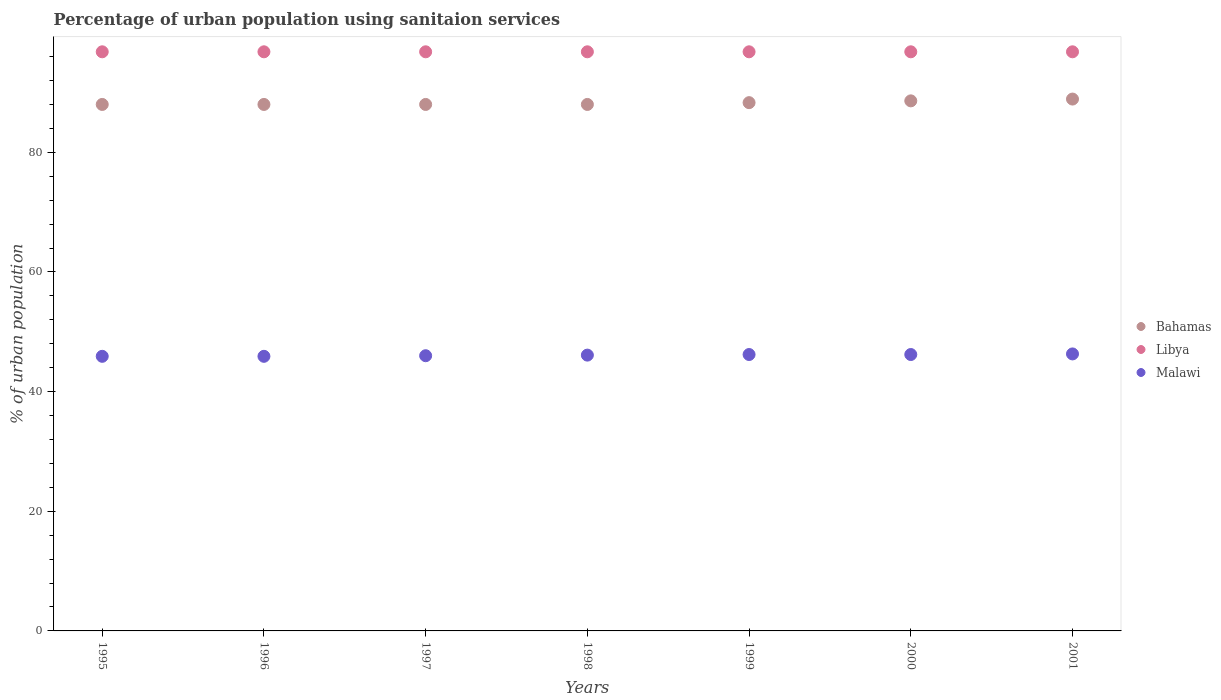Across all years, what is the maximum percentage of urban population using sanitaion services in Libya?
Ensure brevity in your answer.  96.8. Across all years, what is the minimum percentage of urban population using sanitaion services in Libya?
Offer a terse response. 96.8. In which year was the percentage of urban population using sanitaion services in Malawi maximum?
Ensure brevity in your answer.  2001. In which year was the percentage of urban population using sanitaion services in Libya minimum?
Provide a short and direct response. 1995. What is the total percentage of urban population using sanitaion services in Bahamas in the graph?
Offer a very short reply. 617.8. What is the difference between the percentage of urban population using sanitaion services in Malawi in 1999 and that in 2001?
Offer a terse response. -0.1. What is the difference between the percentage of urban population using sanitaion services in Libya in 1995 and the percentage of urban population using sanitaion services in Malawi in 1996?
Your answer should be very brief. 50.9. What is the average percentage of urban population using sanitaion services in Bahamas per year?
Your answer should be very brief. 88.26. In the year 1996, what is the difference between the percentage of urban population using sanitaion services in Malawi and percentage of urban population using sanitaion services in Libya?
Provide a short and direct response. -50.9. In how many years, is the percentage of urban population using sanitaion services in Bahamas greater than 88 %?
Provide a succinct answer. 3. What is the ratio of the percentage of urban population using sanitaion services in Malawi in 1997 to that in 2001?
Make the answer very short. 0.99. Is the difference between the percentage of urban population using sanitaion services in Malawi in 1998 and 1999 greater than the difference between the percentage of urban population using sanitaion services in Libya in 1998 and 1999?
Your response must be concise. No. What is the difference between the highest and the second highest percentage of urban population using sanitaion services in Bahamas?
Offer a terse response. 0.3. What is the difference between the highest and the lowest percentage of urban population using sanitaion services in Bahamas?
Make the answer very short. 0.9. Is the percentage of urban population using sanitaion services in Libya strictly greater than the percentage of urban population using sanitaion services in Bahamas over the years?
Your response must be concise. Yes. Is the percentage of urban population using sanitaion services in Libya strictly less than the percentage of urban population using sanitaion services in Malawi over the years?
Keep it short and to the point. No. How many years are there in the graph?
Ensure brevity in your answer.  7. What is the difference between two consecutive major ticks on the Y-axis?
Offer a terse response. 20. Does the graph contain grids?
Keep it short and to the point. No. Where does the legend appear in the graph?
Ensure brevity in your answer.  Center right. How many legend labels are there?
Give a very brief answer. 3. How are the legend labels stacked?
Your answer should be compact. Vertical. What is the title of the graph?
Offer a terse response. Percentage of urban population using sanitaion services. Does "Austria" appear as one of the legend labels in the graph?
Give a very brief answer. No. What is the label or title of the X-axis?
Keep it short and to the point. Years. What is the label or title of the Y-axis?
Give a very brief answer. % of urban population. What is the % of urban population in Bahamas in 1995?
Make the answer very short. 88. What is the % of urban population in Libya in 1995?
Provide a short and direct response. 96.8. What is the % of urban population in Malawi in 1995?
Offer a terse response. 45.9. What is the % of urban population of Libya in 1996?
Your answer should be compact. 96.8. What is the % of urban population of Malawi in 1996?
Your response must be concise. 45.9. What is the % of urban population of Bahamas in 1997?
Your response must be concise. 88. What is the % of urban population of Libya in 1997?
Make the answer very short. 96.8. What is the % of urban population of Malawi in 1997?
Your answer should be compact. 46. What is the % of urban population in Bahamas in 1998?
Provide a succinct answer. 88. What is the % of urban population of Libya in 1998?
Offer a very short reply. 96.8. What is the % of urban population of Malawi in 1998?
Give a very brief answer. 46.1. What is the % of urban population of Bahamas in 1999?
Give a very brief answer. 88.3. What is the % of urban population in Libya in 1999?
Your response must be concise. 96.8. What is the % of urban population in Malawi in 1999?
Your response must be concise. 46.2. What is the % of urban population in Bahamas in 2000?
Make the answer very short. 88.6. What is the % of urban population of Libya in 2000?
Keep it short and to the point. 96.8. What is the % of urban population of Malawi in 2000?
Offer a very short reply. 46.2. What is the % of urban population of Bahamas in 2001?
Provide a short and direct response. 88.9. What is the % of urban population of Libya in 2001?
Ensure brevity in your answer.  96.8. What is the % of urban population of Malawi in 2001?
Provide a short and direct response. 46.3. Across all years, what is the maximum % of urban population in Bahamas?
Give a very brief answer. 88.9. Across all years, what is the maximum % of urban population of Libya?
Offer a very short reply. 96.8. Across all years, what is the maximum % of urban population in Malawi?
Offer a terse response. 46.3. Across all years, what is the minimum % of urban population in Libya?
Your answer should be compact. 96.8. Across all years, what is the minimum % of urban population in Malawi?
Provide a succinct answer. 45.9. What is the total % of urban population of Bahamas in the graph?
Give a very brief answer. 617.8. What is the total % of urban population in Libya in the graph?
Your answer should be very brief. 677.6. What is the total % of urban population of Malawi in the graph?
Your answer should be very brief. 322.6. What is the difference between the % of urban population of Malawi in 1995 and that in 1996?
Your response must be concise. 0. What is the difference between the % of urban population in Bahamas in 1995 and that in 1997?
Your answer should be compact. 0. What is the difference between the % of urban population of Bahamas in 1995 and that in 1998?
Your response must be concise. 0. What is the difference between the % of urban population in Libya in 1995 and that in 1998?
Offer a terse response. 0. What is the difference between the % of urban population in Malawi in 1995 and that in 1998?
Give a very brief answer. -0.2. What is the difference between the % of urban population in Libya in 1995 and that in 1999?
Keep it short and to the point. 0. What is the difference between the % of urban population of Bahamas in 1995 and that in 2000?
Make the answer very short. -0.6. What is the difference between the % of urban population in Libya in 1995 and that in 2000?
Give a very brief answer. 0. What is the difference between the % of urban population of Malawi in 1995 and that in 2000?
Give a very brief answer. -0.3. What is the difference between the % of urban population of Libya in 1995 and that in 2001?
Offer a terse response. 0. What is the difference between the % of urban population of Malawi in 1995 and that in 2001?
Provide a short and direct response. -0.4. What is the difference between the % of urban population in Bahamas in 1996 and that in 1997?
Offer a very short reply. 0. What is the difference between the % of urban population in Libya in 1996 and that in 1997?
Provide a succinct answer. 0. What is the difference between the % of urban population of Bahamas in 1996 and that in 1999?
Keep it short and to the point. -0.3. What is the difference between the % of urban population of Libya in 1996 and that in 1999?
Make the answer very short. 0. What is the difference between the % of urban population of Malawi in 1996 and that in 1999?
Offer a very short reply. -0.3. What is the difference between the % of urban population of Bahamas in 1996 and that in 2000?
Provide a succinct answer. -0.6. What is the difference between the % of urban population in Malawi in 1996 and that in 2000?
Make the answer very short. -0.3. What is the difference between the % of urban population in Libya in 1996 and that in 2001?
Your answer should be very brief. 0. What is the difference between the % of urban population of Malawi in 1996 and that in 2001?
Your answer should be compact. -0.4. What is the difference between the % of urban population in Malawi in 1997 and that in 1998?
Offer a terse response. -0.1. What is the difference between the % of urban population in Libya in 1997 and that in 1999?
Provide a short and direct response. 0. What is the difference between the % of urban population of Bahamas in 1997 and that in 2000?
Keep it short and to the point. -0.6. What is the difference between the % of urban population of Malawi in 1997 and that in 2000?
Offer a terse response. -0.2. What is the difference between the % of urban population of Libya in 1997 and that in 2001?
Your answer should be compact. 0. What is the difference between the % of urban population in Malawi in 1997 and that in 2001?
Offer a very short reply. -0.3. What is the difference between the % of urban population of Libya in 1998 and that in 1999?
Ensure brevity in your answer.  0. What is the difference between the % of urban population of Bahamas in 1998 and that in 2000?
Your response must be concise. -0.6. What is the difference between the % of urban population in Libya in 1998 and that in 2000?
Give a very brief answer. 0. What is the difference between the % of urban population of Malawi in 1998 and that in 2000?
Provide a short and direct response. -0.1. What is the difference between the % of urban population in Bahamas in 1998 and that in 2001?
Make the answer very short. -0.9. What is the difference between the % of urban population of Bahamas in 1999 and that in 2000?
Offer a terse response. -0.3. What is the difference between the % of urban population in Libya in 1999 and that in 2000?
Your answer should be compact. 0. What is the difference between the % of urban population of Bahamas in 1999 and that in 2001?
Offer a very short reply. -0.6. What is the difference between the % of urban population of Malawi in 2000 and that in 2001?
Offer a terse response. -0.1. What is the difference between the % of urban population of Bahamas in 1995 and the % of urban population of Malawi in 1996?
Your answer should be very brief. 42.1. What is the difference between the % of urban population in Libya in 1995 and the % of urban population in Malawi in 1996?
Ensure brevity in your answer.  50.9. What is the difference between the % of urban population in Bahamas in 1995 and the % of urban population in Libya in 1997?
Your response must be concise. -8.8. What is the difference between the % of urban population of Libya in 1995 and the % of urban population of Malawi in 1997?
Your answer should be compact. 50.8. What is the difference between the % of urban population of Bahamas in 1995 and the % of urban population of Libya in 1998?
Provide a short and direct response. -8.8. What is the difference between the % of urban population in Bahamas in 1995 and the % of urban population in Malawi in 1998?
Give a very brief answer. 41.9. What is the difference between the % of urban population in Libya in 1995 and the % of urban population in Malawi in 1998?
Provide a short and direct response. 50.7. What is the difference between the % of urban population of Bahamas in 1995 and the % of urban population of Malawi in 1999?
Your response must be concise. 41.8. What is the difference between the % of urban population in Libya in 1995 and the % of urban population in Malawi in 1999?
Give a very brief answer. 50.6. What is the difference between the % of urban population in Bahamas in 1995 and the % of urban population in Libya in 2000?
Provide a succinct answer. -8.8. What is the difference between the % of urban population of Bahamas in 1995 and the % of urban population of Malawi in 2000?
Ensure brevity in your answer.  41.8. What is the difference between the % of urban population in Libya in 1995 and the % of urban population in Malawi in 2000?
Your response must be concise. 50.6. What is the difference between the % of urban population of Bahamas in 1995 and the % of urban population of Libya in 2001?
Your answer should be compact. -8.8. What is the difference between the % of urban population of Bahamas in 1995 and the % of urban population of Malawi in 2001?
Your response must be concise. 41.7. What is the difference between the % of urban population in Libya in 1995 and the % of urban population in Malawi in 2001?
Keep it short and to the point. 50.5. What is the difference between the % of urban population in Bahamas in 1996 and the % of urban population in Malawi in 1997?
Your answer should be very brief. 42. What is the difference between the % of urban population in Libya in 1996 and the % of urban population in Malawi in 1997?
Offer a terse response. 50.8. What is the difference between the % of urban population in Bahamas in 1996 and the % of urban population in Libya in 1998?
Provide a succinct answer. -8.8. What is the difference between the % of urban population in Bahamas in 1996 and the % of urban population in Malawi in 1998?
Provide a succinct answer. 41.9. What is the difference between the % of urban population in Libya in 1996 and the % of urban population in Malawi in 1998?
Offer a terse response. 50.7. What is the difference between the % of urban population of Bahamas in 1996 and the % of urban population of Libya in 1999?
Offer a very short reply. -8.8. What is the difference between the % of urban population in Bahamas in 1996 and the % of urban population in Malawi in 1999?
Provide a short and direct response. 41.8. What is the difference between the % of urban population in Libya in 1996 and the % of urban population in Malawi in 1999?
Provide a succinct answer. 50.6. What is the difference between the % of urban population of Bahamas in 1996 and the % of urban population of Malawi in 2000?
Keep it short and to the point. 41.8. What is the difference between the % of urban population of Libya in 1996 and the % of urban population of Malawi in 2000?
Offer a terse response. 50.6. What is the difference between the % of urban population in Bahamas in 1996 and the % of urban population in Libya in 2001?
Ensure brevity in your answer.  -8.8. What is the difference between the % of urban population of Bahamas in 1996 and the % of urban population of Malawi in 2001?
Offer a terse response. 41.7. What is the difference between the % of urban population in Libya in 1996 and the % of urban population in Malawi in 2001?
Make the answer very short. 50.5. What is the difference between the % of urban population of Bahamas in 1997 and the % of urban population of Malawi in 1998?
Make the answer very short. 41.9. What is the difference between the % of urban population in Libya in 1997 and the % of urban population in Malawi in 1998?
Provide a short and direct response. 50.7. What is the difference between the % of urban population of Bahamas in 1997 and the % of urban population of Malawi in 1999?
Provide a short and direct response. 41.8. What is the difference between the % of urban population of Libya in 1997 and the % of urban population of Malawi in 1999?
Offer a terse response. 50.6. What is the difference between the % of urban population in Bahamas in 1997 and the % of urban population in Malawi in 2000?
Offer a terse response. 41.8. What is the difference between the % of urban population of Libya in 1997 and the % of urban population of Malawi in 2000?
Make the answer very short. 50.6. What is the difference between the % of urban population in Bahamas in 1997 and the % of urban population in Malawi in 2001?
Your answer should be very brief. 41.7. What is the difference between the % of urban population in Libya in 1997 and the % of urban population in Malawi in 2001?
Offer a very short reply. 50.5. What is the difference between the % of urban population in Bahamas in 1998 and the % of urban population in Libya in 1999?
Keep it short and to the point. -8.8. What is the difference between the % of urban population of Bahamas in 1998 and the % of urban population of Malawi in 1999?
Keep it short and to the point. 41.8. What is the difference between the % of urban population in Libya in 1998 and the % of urban population in Malawi in 1999?
Your answer should be compact. 50.6. What is the difference between the % of urban population of Bahamas in 1998 and the % of urban population of Malawi in 2000?
Make the answer very short. 41.8. What is the difference between the % of urban population in Libya in 1998 and the % of urban population in Malawi in 2000?
Make the answer very short. 50.6. What is the difference between the % of urban population of Bahamas in 1998 and the % of urban population of Malawi in 2001?
Give a very brief answer. 41.7. What is the difference between the % of urban population in Libya in 1998 and the % of urban population in Malawi in 2001?
Provide a succinct answer. 50.5. What is the difference between the % of urban population of Bahamas in 1999 and the % of urban population of Libya in 2000?
Make the answer very short. -8.5. What is the difference between the % of urban population of Bahamas in 1999 and the % of urban population of Malawi in 2000?
Ensure brevity in your answer.  42.1. What is the difference between the % of urban population of Libya in 1999 and the % of urban population of Malawi in 2000?
Give a very brief answer. 50.6. What is the difference between the % of urban population in Bahamas in 1999 and the % of urban population in Libya in 2001?
Provide a succinct answer. -8.5. What is the difference between the % of urban population of Libya in 1999 and the % of urban population of Malawi in 2001?
Offer a very short reply. 50.5. What is the difference between the % of urban population of Bahamas in 2000 and the % of urban population of Malawi in 2001?
Make the answer very short. 42.3. What is the difference between the % of urban population of Libya in 2000 and the % of urban population of Malawi in 2001?
Provide a short and direct response. 50.5. What is the average % of urban population in Bahamas per year?
Your answer should be very brief. 88.26. What is the average % of urban population of Libya per year?
Provide a succinct answer. 96.8. What is the average % of urban population in Malawi per year?
Provide a short and direct response. 46.09. In the year 1995, what is the difference between the % of urban population in Bahamas and % of urban population in Malawi?
Offer a very short reply. 42.1. In the year 1995, what is the difference between the % of urban population of Libya and % of urban population of Malawi?
Provide a short and direct response. 50.9. In the year 1996, what is the difference between the % of urban population in Bahamas and % of urban population in Malawi?
Offer a very short reply. 42.1. In the year 1996, what is the difference between the % of urban population of Libya and % of urban population of Malawi?
Provide a succinct answer. 50.9. In the year 1997, what is the difference between the % of urban population of Bahamas and % of urban population of Libya?
Your answer should be very brief. -8.8. In the year 1997, what is the difference between the % of urban population in Bahamas and % of urban population in Malawi?
Ensure brevity in your answer.  42. In the year 1997, what is the difference between the % of urban population of Libya and % of urban population of Malawi?
Your response must be concise. 50.8. In the year 1998, what is the difference between the % of urban population of Bahamas and % of urban population of Libya?
Make the answer very short. -8.8. In the year 1998, what is the difference between the % of urban population of Bahamas and % of urban population of Malawi?
Offer a very short reply. 41.9. In the year 1998, what is the difference between the % of urban population in Libya and % of urban population in Malawi?
Give a very brief answer. 50.7. In the year 1999, what is the difference between the % of urban population of Bahamas and % of urban population of Malawi?
Provide a short and direct response. 42.1. In the year 1999, what is the difference between the % of urban population in Libya and % of urban population in Malawi?
Give a very brief answer. 50.6. In the year 2000, what is the difference between the % of urban population in Bahamas and % of urban population in Libya?
Ensure brevity in your answer.  -8.2. In the year 2000, what is the difference between the % of urban population in Bahamas and % of urban population in Malawi?
Your response must be concise. 42.4. In the year 2000, what is the difference between the % of urban population of Libya and % of urban population of Malawi?
Make the answer very short. 50.6. In the year 2001, what is the difference between the % of urban population of Bahamas and % of urban population of Malawi?
Provide a short and direct response. 42.6. In the year 2001, what is the difference between the % of urban population of Libya and % of urban population of Malawi?
Offer a terse response. 50.5. What is the ratio of the % of urban population in Libya in 1995 to that in 1996?
Offer a very short reply. 1. What is the ratio of the % of urban population of Malawi in 1995 to that in 1996?
Make the answer very short. 1. What is the ratio of the % of urban population in Bahamas in 1995 to that in 1997?
Offer a terse response. 1. What is the ratio of the % of urban population in Bahamas in 1995 to that in 1998?
Your answer should be compact. 1. What is the ratio of the % of urban population of Malawi in 1995 to that in 1998?
Your answer should be very brief. 1. What is the ratio of the % of urban population in Libya in 1995 to that in 1999?
Offer a very short reply. 1. What is the ratio of the % of urban population of Malawi in 1995 to that in 1999?
Provide a short and direct response. 0.99. What is the ratio of the % of urban population of Libya in 1995 to that in 2000?
Ensure brevity in your answer.  1. What is the ratio of the % of urban population of Malawi in 1995 to that in 2000?
Provide a short and direct response. 0.99. What is the ratio of the % of urban population of Bahamas in 1995 to that in 2001?
Provide a short and direct response. 0.99. What is the ratio of the % of urban population in Malawi in 1995 to that in 2001?
Offer a terse response. 0.99. What is the ratio of the % of urban population in Libya in 1996 to that in 1997?
Offer a very short reply. 1. What is the ratio of the % of urban population in Malawi in 1996 to that in 1998?
Give a very brief answer. 1. What is the ratio of the % of urban population in Bahamas in 1996 to that in 1999?
Keep it short and to the point. 1. What is the ratio of the % of urban population in Libya in 1996 to that in 1999?
Your answer should be very brief. 1. What is the ratio of the % of urban population in Libya in 1996 to that in 2000?
Provide a short and direct response. 1. What is the ratio of the % of urban population in Bahamas in 1996 to that in 2001?
Offer a terse response. 0.99. What is the ratio of the % of urban population of Libya in 1996 to that in 2001?
Offer a terse response. 1. What is the ratio of the % of urban population in Malawi in 1996 to that in 2001?
Your answer should be compact. 0.99. What is the ratio of the % of urban population in Libya in 1997 to that in 1998?
Give a very brief answer. 1. What is the ratio of the % of urban population of Bahamas in 1997 to that in 1999?
Make the answer very short. 1. What is the ratio of the % of urban population in Malawi in 1997 to that in 1999?
Keep it short and to the point. 1. What is the ratio of the % of urban population of Libya in 1997 to that in 2000?
Offer a terse response. 1. What is the ratio of the % of urban population in Bahamas in 1997 to that in 2001?
Provide a succinct answer. 0.99. What is the ratio of the % of urban population in Libya in 1997 to that in 2001?
Your answer should be compact. 1. What is the ratio of the % of urban population in Malawi in 1997 to that in 2001?
Your response must be concise. 0.99. What is the ratio of the % of urban population of Bahamas in 1998 to that in 1999?
Ensure brevity in your answer.  1. What is the ratio of the % of urban population of Bahamas in 1998 to that in 2001?
Ensure brevity in your answer.  0.99. What is the ratio of the % of urban population in Libya in 1998 to that in 2001?
Provide a short and direct response. 1. What is the ratio of the % of urban population of Bahamas in 1999 to that in 2000?
Ensure brevity in your answer.  1. What is the ratio of the % of urban population of Malawi in 1999 to that in 2000?
Your answer should be compact. 1. What is the ratio of the % of urban population in Bahamas in 1999 to that in 2001?
Give a very brief answer. 0.99. What is the ratio of the % of urban population of Libya in 1999 to that in 2001?
Offer a terse response. 1. What is the ratio of the % of urban population in Malawi in 1999 to that in 2001?
Your answer should be very brief. 1. What is the ratio of the % of urban population of Bahamas in 2000 to that in 2001?
Provide a short and direct response. 1. What is the ratio of the % of urban population of Libya in 2000 to that in 2001?
Offer a very short reply. 1. What is the difference between the highest and the second highest % of urban population of Bahamas?
Your answer should be compact. 0.3. What is the difference between the highest and the second highest % of urban population in Libya?
Your response must be concise. 0. What is the difference between the highest and the second highest % of urban population in Malawi?
Offer a very short reply. 0.1. What is the difference between the highest and the lowest % of urban population of Bahamas?
Provide a short and direct response. 0.9. What is the difference between the highest and the lowest % of urban population in Libya?
Ensure brevity in your answer.  0. 